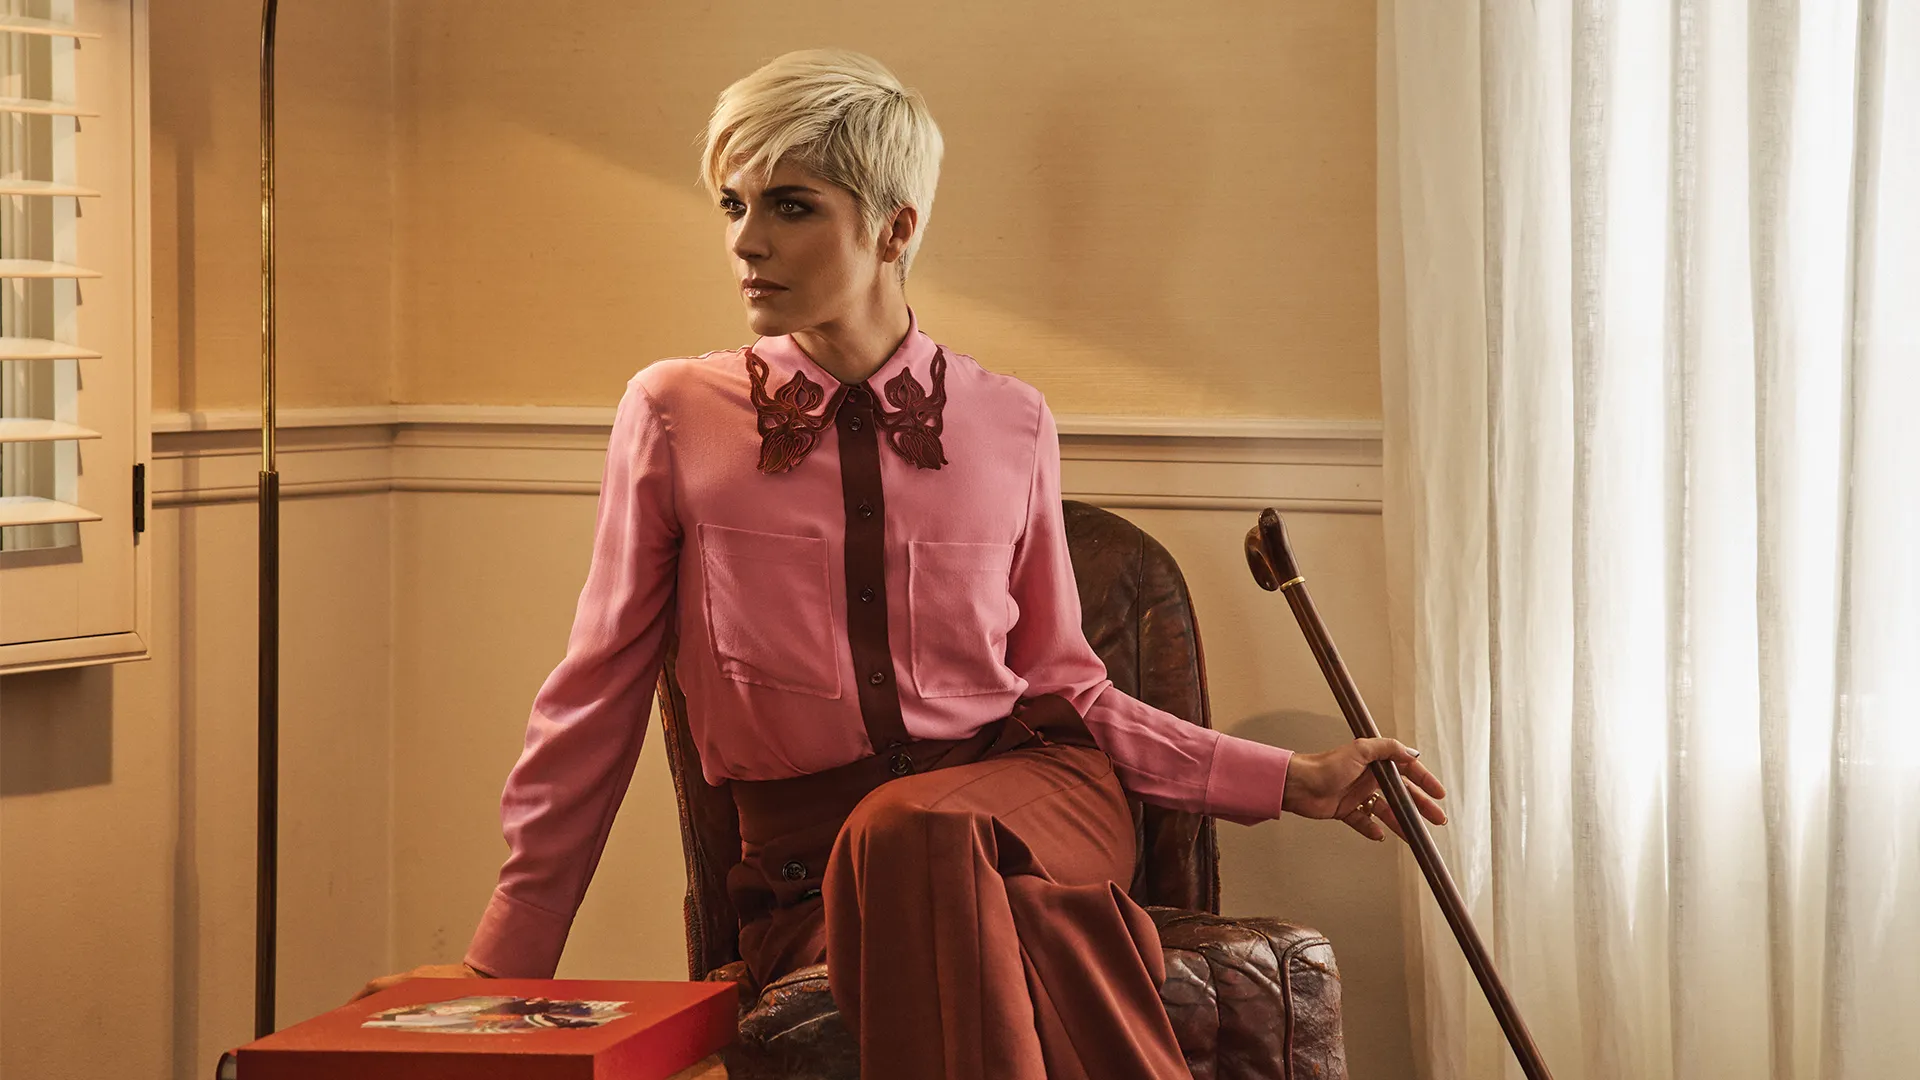Can you invent a backstory for the woman in this image? Evelyn had always been an independent spirit. A former ballet dancer, she had traveled the world, but an unexpected illness brought her career to an abrupt end. The cane in her hand is a testament to her battle with this illness, which she faced with unwavering courage. Now, Evelyn channels her passion for the arts into teaching and mentoring young dancers. The red box on her lap contains cherished memories – photographs, trinkets, and letters from her students and fans, reminders of the lives she has touched. What else is inside the red box that adds more details to Evelyn’s story? Inside the red box is a delicate silver locket containing a picture of Evelyn and her mentor, taken on the day she first performed as a principal dancer. There is also a worn-out ticket stub from her debut performance, a constant reminder of her triumph over adversity. Additionally, nestled within is an old rusted key – a symbol of the theater where she performed her first solo ballet, a place that holds countless memories of her artistic journey. If Evelyn could send a message to her younger self, what would it be? Evelyn would tell her younger self, 'Embrace every moment, every challenge, and every triumph. Your journey will be filled with unexpected twists and turns, but in every setback, you'll find the strength to rise again. Keep your passion and let it guide you through the darkest times. Remember, the love and support from those you've inspired will be your greatest achievement.' 